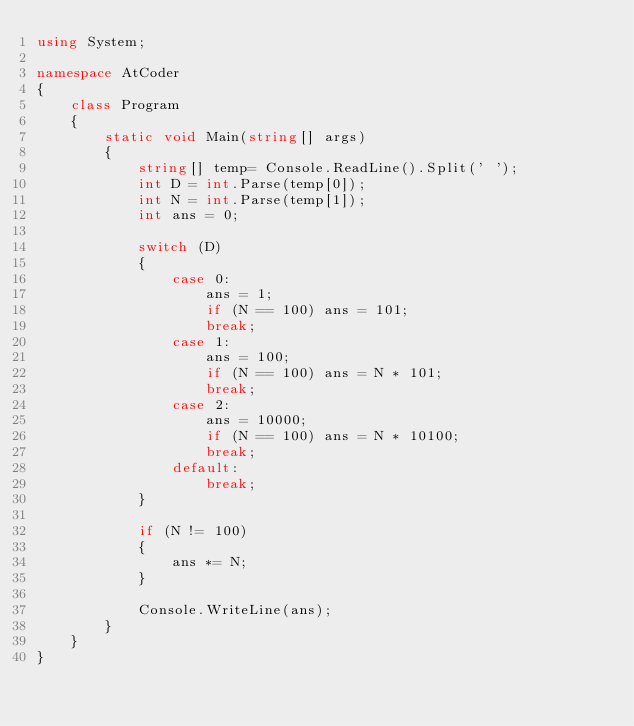Convert code to text. <code><loc_0><loc_0><loc_500><loc_500><_C#_>using System;

namespace AtCoder
{
    class Program
    {
        static void Main(string[] args)
        {  
            string[] temp= Console.ReadLine().Split(' ');
            int D = int.Parse(temp[0]);
            int N = int.Parse(temp[1]);
            int ans = 0;

            switch (D)
            {
                case 0:
                    ans = 1;
                    if (N == 100) ans = 101;
                    break;
                case 1:
                    ans = 100;
                    if (N == 100) ans = N * 101;
                    break;
                case 2:
                    ans = 10000;
                    if (N == 100) ans = N * 10100;
                    break;
                default:
                    break;
            }

            if (N != 100)
            {
                ans *= N;
            }

            Console.WriteLine(ans);
        }
    }
}</code> 